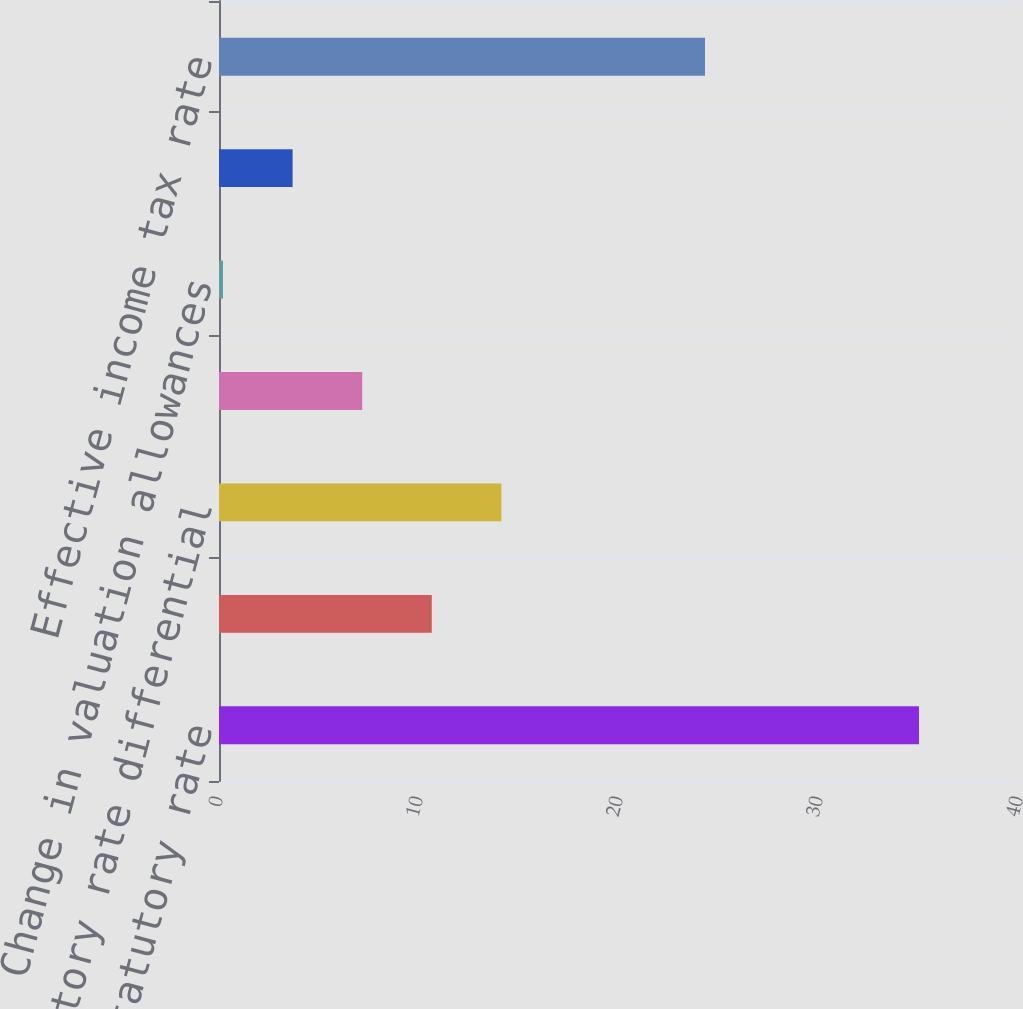Convert chart. <chart><loc_0><loc_0><loc_500><loc_500><bar_chart><fcel>US federal statutory rate<fcel>State income tax net of<fcel>Statutory rate differential<fcel>Adjustments to reserves and<fcel>Change in valuation allowances<fcel>Other net<fcel>Effective income tax rate<nl><fcel>35<fcel>10.64<fcel>14.12<fcel>7.16<fcel>0.2<fcel>3.68<fcel>24.3<nl></chart> 